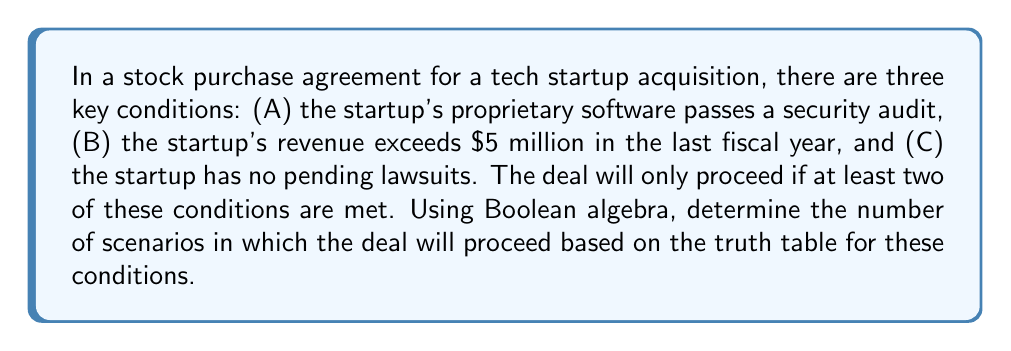Provide a solution to this math problem. Let's approach this step-by-step:

1) First, we need to set up the truth table for the three conditions A, B, and C:

   A | B | C
   ---|---|---
   0 | 0 | 0
   0 | 0 | 1
   0 | 1 | 0
   0 | 1 | 1
   1 | 0 | 0
   1 | 0 | 1
   1 | 1 | 0
   1 | 1 | 1

2) The deal proceeds if at least two conditions are met. We can express this using Boolean algebra as:

   $$(A \wedge B) \vee (A \wedge C) \vee (B \wedge C)$$

3) Now, let's evaluate this expression for each row of the truth table:

   A | B | C | (A∧B) | (A∧C) | (B∧C) | Result
   ---|---|---|-------|-------|-------|-------
   0 | 0 | 0 |   0   |   0   |   0   |   0
   0 | 0 | 1 |   0   |   0   |   0   |   0
   0 | 1 | 0 |   0   |   0   |   0   |   0
   0 | 1 | 1 |   0   |   0   |   1   |   1
   1 | 0 | 0 |   0   |   0   |   0   |   0
   1 | 0 | 1 |   0   |   1   |   0   |   1
   1 | 1 | 0 |   1   |   0   |   0   |   1
   1 | 1 | 1 |   1   |   1   |   1   |   1

4) Counting the number of rows where the result is 1, we find that there are 4 scenarios where the deal will proceed.
Answer: 4 